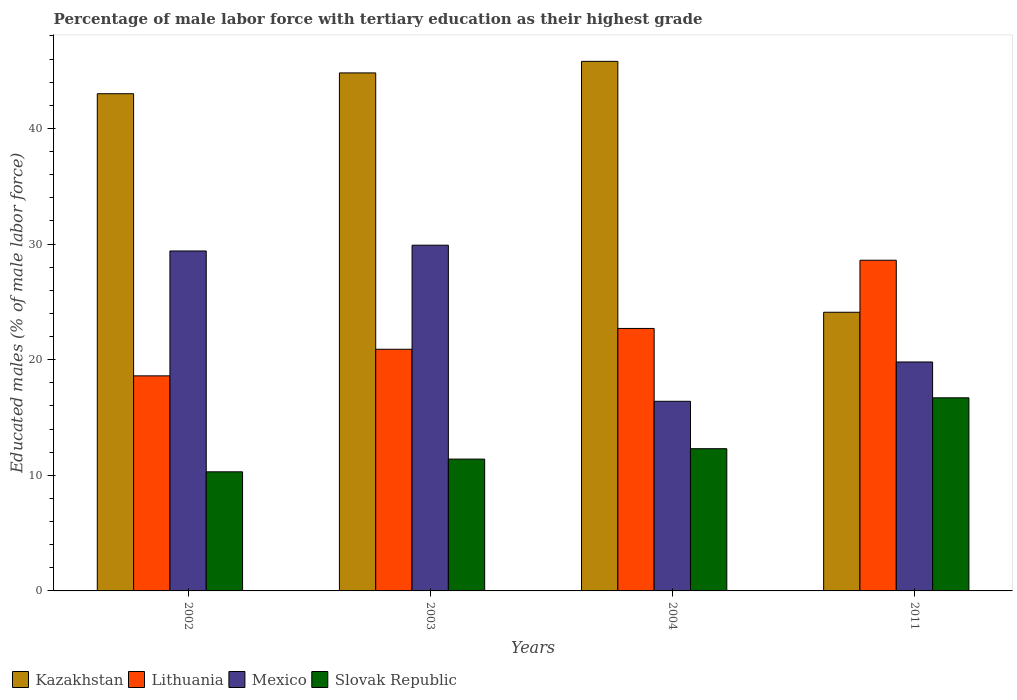In how many cases, is the number of bars for a given year not equal to the number of legend labels?
Provide a succinct answer. 0. What is the percentage of male labor force with tertiary education in Lithuania in 2011?
Ensure brevity in your answer.  28.6. Across all years, what is the maximum percentage of male labor force with tertiary education in Lithuania?
Make the answer very short. 28.6. Across all years, what is the minimum percentage of male labor force with tertiary education in Kazakhstan?
Your answer should be very brief. 24.1. What is the total percentage of male labor force with tertiary education in Mexico in the graph?
Ensure brevity in your answer.  95.5. What is the difference between the percentage of male labor force with tertiary education in Mexico in 2003 and that in 2004?
Your answer should be very brief. 13.5. What is the difference between the percentage of male labor force with tertiary education in Kazakhstan in 2003 and the percentage of male labor force with tertiary education in Mexico in 2004?
Offer a very short reply. 28.4. What is the average percentage of male labor force with tertiary education in Kazakhstan per year?
Your answer should be very brief. 39.42. In the year 2002, what is the difference between the percentage of male labor force with tertiary education in Lithuania and percentage of male labor force with tertiary education in Mexico?
Offer a terse response. -10.8. In how many years, is the percentage of male labor force with tertiary education in Kazakhstan greater than 20 %?
Offer a terse response. 4. What is the ratio of the percentage of male labor force with tertiary education in Lithuania in 2002 to that in 2003?
Your answer should be compact. 0.89. Is the percentage of male labor force with tertiary education in Slovak Republic in 2002 less than that in 2011?
Make the answer very short. Yes. Is the difference between the percentage of male labor force with tertiary education in Lithuania in 2004 and 2011 greater than the difference between the percentage of male labor force with tertiary education in Mexico in 2004 and 2011?
Give a very brief answer. No. What is the difference between the highest and the lowest percentage of male labor force with tertiary education in Slovak Republic?
Provide a short and direct response. 6.4. In how many years, is the percentage of male labor force with tertiary education in Slovak Republic greater than the average percentage of male labor force with tertiary education in Slovak Republic taken over all years?
Keep it short and to the point. 1. What does the 1st bar from the left in 2003 represents?
Your answer should be very brief. Kazakhstan. What does the 2nd bar from the right in 2003 represents?
Offer a terse response. Mexico. What is the difference between two consecutive major ticks on the Y-axis?
Your answer should be very brief. 10. Does the graph contain grids?
Offer a terse response. No. Where does the legend appear in the graph?
Give a very brief answer. Bottom left. What is the title of the graph?
Offer a terse response. Percentage of male labor force with tertiary education as their highest grade. Does "Moldova" appear as one of the legend labels in the graph?
Give a very brief answer. No. What is the label or title of the X-axis?
Ensure brevity in your answer.  Years. What is the label or title of the Y-axis?
Provide a short and direct response. Educated males (% of male labor force). What is the Educated males (% of male labor force) of Kazakhstan in 2002?
Give a very brief answer. 43. What is the Educated males (% of male labor force) in Lithuania in 2002?
Make the answer very short. 18.6. What is the Educated males (% of male labor force) in Mexico in 2002?
Make the answer very short. 29.4. What is the Educated males (% of male labor force) in Slovak Republic in 2002?
Ensure brevity in your answer.  10.3. What is the Educated males (% of male labor force) in Kazakhstan in 2003?
Ensure brevity in your answer.  44.8. What is the Educated males (% of male labor force) in Lithuania in 2003?
Your answer should be very brief. 20.9. What is the Educated males (% of male labor force) in Mexico in 2003?
Give a very brief answer. 29.9. What is the Educated males (% of male labor force) in Slovak Republic in 2003?
Ensure brevity in your answer.  11.4. What is the Educated males (% of male labor force) in Kazakhstan in 2004?
Your answer should be compact. 45.8. What is the Educated males (% of male labor force) of Lithuania in 2004?
Make the answer very short. 22.7. What is the Educated males (% of male labor force) of Mexico in 2004?
Offer a very short reply. 16.4. What is the Educated males (% of male labor force) in Slovak Republic in 2004?
Offer a very short reply. 12.3. What is the Educated males (% of male labor force) of Kazakhstan in 2011?
Your answer should be compact. 24.1. What is the Educated males (% of male labor force) of Lithuania in 2011?
Offer a very short reply. 28.6. What is the Educated males (% of male labor force) in Mexico in 2011?
Ensure brevity in your answer.  19.8. What is the Educated males (% of male labor force) of Slovak Republic in 2011?
Keep it short and to the point. 16.7. Across all years, what is the maximum Educated males (% of male labor force) of Kazakhstan?
Provide a succinct answer. 45.8. Across all years, what is the maximum Educated males (% of male labor force) of Lithuania?
Ensure brevity in your answer.  28.6. Across all years, what is the maximum Educated males (% of male labor force) of Mexico?
Your answer should be very brief. 29.9. Across all years, what is the maximum Educated males (% of male labor force) in Slovak Republic?
Offer a terse response. 16.7. Across all years, what is the minimum Educated males (% of male labor force) in Kazakhstan?
Provide a short and direct response. 24.1. Across all years, what is the minimum Educated males (% of male labor force) in Lithuania?
Keep it short and to the point. 18.6. Across all years, what is the minimum Educated males (% of male labor force) of Mexico?
Offer a terse response. 16.4. Across all years, what is the minimum Educated males (% of male labor force) of Slovak Republic?
Ensure brevity in your answer.  10.3. What is the total Educated males (% of male labor force) of Kazakhstan in the graph?
Give a very brief answer. 157.7. What is the total Educated males (% of male labor force) in Lithuania in the graph?
Offer a terse response. 90.8. What is the total Educated males (% of male labor force) of Mexico in the graph?
Provide a short and direct response. 95.5. What is the total Educated males (% of male labor force) of Slovak Republic in the graph?
Offer a terse response. 50.7. What is the difference between the Educated males (% of male labor force) in Kazakhstan in 2002 and that in 2003?
Keep it short and to the point. -1.8. What is the difference between the Educated males (% of male labor force) of Mexico in 2002 and that in 2003?
Keep it short and to the point. -0.5. What is the difference between the Educated males (% of male labor force) of Kazakhstan in 2002 and that in 2004?
Offer a terse response. -2.8. What is the difference between the Educated males (% of male labor force) in Lithuania in 2002 and that in 2011?
Your answer should be compact. -10. What is the difference between the Educated males (% of male labor force) of Slovak Republic in 2002 and that in 2011?
Your answer should be very brief. -6.4. What is the difference between the Educated males (% of male labor force) in Kazakhstan in 2003 and that in 2011?
Provide a succinct answer. 20.7. What is the difference between the Educated males (% of male labor force) of Lithuania in 2003 and that in 2011?
Keep it short and to the point. -7.7. What is the difference between the Educated males (% of male labor force) in Kazakhstan in 2004 and that in 2011?
Provide a short and direct response. 21.7. What is the difference between the Educated males (% of male labor force) of Lithuania in 2004 and that in 2011?
Offer a terse response. -5.9. What is the difference between the Educated males (% of male labor force) of Kazakhstan in 2002 and the Educated males (% of male labor force) of Lithuania in 2003?
Give a very brief answer. 22.1. What is the difference between the Educated males (% of male labor force) in Kazakhstan in 2002 and the Educated males (% of male labor force) in Slovak Republic in 2003?
Give a very brief answer. 31.6. What is the difference between the Educated males (% of male labor force) of Mexico in 2002 and the Educated males (% of male labor force) of Slovak Republic in 2003?
Make the answer very short. 18. What is the difference between the Educated males (% of male labor force) in Kazakhstan in 2002 and the Educated males (% of male labor force) in Lithuania in 2004?
Give a very brief answer. 20.3. What is the difference between the Educated males (% of male labor force) of Kazakhstan in 2002 and the Educated males (% of male labor force) of Mexico in 2004?
Your answer should be compact. 26.6. What is the difference between the Educated males (% of male labor force) of Kazakhstan in 2002 and the Educated males (% of male labor force) of Slovak Republic in 2004?
Provide a short and direct response. 30.7. What is the difference between the Educated males (% of male labor force) of Lithuania in 2002 and the Educated males (% of male labor force) of Mexico in 2004?
Offer a very short reply. 2.2. What is the difference between the Educated males (% of male labor force) in Lithuania in 2002 and the Educated males (% of male labor force) in Slovak Republic in 2004?
Give a very brief answer. 6.3. What is the difference between the Educated males (% of male labor force) of Mexico in 2002 and the Educated males (% of male labor force) of Slovak Republic in 2004?
Provide a succinct answer. 17.1. What is the difference between the Educated males (% of male labor force) in Kazakhstan in 2002 and the Educated males (% of male labor force) in Lithuania in 2011?
Offer a terse response. 14.4. What is the difference between the Educated males (% of male labor force) of Kazakhstan in 2002 and the Educated males (% of male labor force) of Mexico in 2011?
Give a very brief answer. 23.2. What is the difference between the Educated males (% of male labor force) in Kazakhstan in 2002 and the Educated males (% of male labor force) in Slovak Republic in 2011?
Give a very brief answer. 26.3. What is the difference between the Educated males (% of male labor force) in Lithuania in 2002 and the Educated males (% of male labor force) in Mexico in 2011?
Provide a short and direct response. -1.2. What is the difference between the Educated males (% of male labor force) in Lithuania in 2002 and the Educated males (% of male labor force) in Slovak Republic in 2011?
Give a very brief answer. 1.9. What is the difference between the Educated males (% of male labor force) in Kazakhstan in 2003 and the Educated males (% of male labor force) in Lithuania in 2004?
Ensure brevity in your answer.  22.1. What is the difference between the Educated males (% of male labor force) in Kazakhstan in 2003 and the Educated males (% of male labor force) in Mexico in 2004?
Ensure brevity in your answer.  28.4. What is the difference between the Educated males (% of male labor force) in Kazakhstan in 2003 and the Educated males (% of male labor force) in Slovak Republic in 2004?
Offer a terse response. 32.5. What is the difference between the Educated males (% of male labor force) of Lithuania in 2003 and the Educated males (% of male labor force) of Mexico in 2004?
Your answer should be very brief. 4.5. What is the difference between the Educated males (% of male labor force) in Lithuania in 2003 and the Educated males (% of male labor force) in Slovak Republic in 2004?
Provide a short and direct response. 8.6. What is the difference between the Educated males (% of male labor force) in Mexico in 2003 and the Educated males (% of male labor force) in Slovak Republic in 2004?
Offer a very short reply. 17.6. What is the difference between the Educated males (% of male labor force) of Kazakhstan in 2003 and the Educated males (% of male labor force) of Lithuania in 2011?
Your response must be concise. 16.2. What is the difference between the Educated males (% of male labor force) of Kazakhstan in 2003 and the Educated males (% of male labor force) of Mexico in 2011?
Provide a succinct answer. 25. What is the difference between the Educated males (% of male labor force) in Kazakhstan in 2003 and the Educated males (% of male labor force) in Slovak Republic in 2011?
Ensure brevity in your answer.  28.1. What is the difference between the Educated males (% of male labor force) in Lithuania in 2003 and the Educated males (% of male labor force) in Mexico in 2011?
Your answer should be compact. 1.1. What is the difference between the Educated males (% of male labor force) of Kazakhstan in 2004 and the Educated males (% of male labor force) of Lithuania in 2011?
Give a very brief answer. 17.2. What is the difference between the Educated males (% of male labor force) of Kazakhstan in 2004 and the Educated males (% of male labor force) of Mexico in 2011?
Provide a succinct answer. 26. What is the difference between the Educated males (% of male labor force) in Kazakhstan in 2004 and the Educated males (% of male labor force) in Slovak Republic in 2011?
Your response must be concise. 29.1. What is the difference between the Educated males (% of male labor force) of Lithuania in 2004 and the Educated males (% of male labor force) of Mexico in 2011?
Make the answer very short. 2.9. What is the average Educated males (% of male labor force) of Kazakhstan per year?
Offer a terse response. 39.42. What is the average Educated males (% of male labor force) in Lithuania per year?
Make the answer very short. 22.7. What is the average Educated males (% of male labor force) in Mexico per year?
Give a very brief answer. 23.88. What is the average Educated males (% of male labor force) of Slovak Republic per year?
Make the answer very short. 12.68. In the year 2002, what is the difference between the Educated males (% of male labor force) in Kazakhstan and Educated males (% of male labor force) in Lithuania?
Your response must be concise. 24.4. In the year 2002, what is the difference between the Educated males (% of male labor force) in Kazakhstan and Educated males (% of male labor force) in Slovak Republic?
Ensure brevity in your answer.  32.7. In the year 2003, what is the difference between the Educated males (% of male labor force) of Kazakhstan and Educated males (% of male labor force) of Lithuania?
Your answer should be very brief. 23.9. In the year 2003, what is the difference between the Educated males (% of male labor force) of Kazakhstan and Educated males (% of male labor force) of Mexico?
Offer a very short reply. 14.9. In the year 2003, what is the difference between the Educated males (% of male labor force) in Kazakhstan and Educated males (% of male labor force) in Slovak Republic?
Provide a short and direct response. 33.4. In the year 2003, what is the difference between the Educated males (% of male labor force) in Lithuania and Educated males (% of male labor force) in Mexico?
Your answer should be compact. -9. In the year 2003, what is the difference between the Educated males (% of male labor force) in Lithuania and Educated males (% of male labor force) in Slovak Republic?
Your answer should be very brief. 9.5. In the year 2003, what is the difference between the Educated males (% of male labor force) of Mexico and Educated males (% of male labor force) of Slovak Republic?
Give a very brief answer. 18.5. In the year 2004, what is the difference between the Educated males (% of male labor force) in Kazakhstan and Educated males (% of male labor force) in Lithuania?
Provide a short and direct response. 23.1. In the year 2004, what is the difference between the Educated males (% of male labor force) in Kazakhstan and Educated males (% of male labor force) in Mexico?
Offer a terse response. 29.4. In the year 2004, what is the difference between the Educated males (% of male labor force) in Kazakhstan and Educated males (% of male labor force) in Slovak Republic?
Provide a succinct answer. 33.5. In the year 2004, what is the difference between the Educated males (% of male labor force) in Mexico and Educated males (% of male labor force) in Slovak Republic?
Offer a very short reply. 4.1. In the year 2011, what is the difference between the Educated males (% of male labor force) of Kazakhstan and Educated males (% of male labor force) of Lithuania?
Offer a very short reply. -4.5. In the year 2011, what is the difference between the Educated males (% of male labor force) of Kazakhstan and Educated males (% of male labor force) of Slovak Republic?
Ensure brevity in your answer.  7.4. In the year 2011, what is the difference between the Educated males (% of male labor force) in Lithuania and Educated males (% of male labor force) in Mexico?
Offer a terse response. 8.8. In the year 2011, what is the difference between the Educated males (% of male labor force) of Lithuania and Educated males (% of male labor force) of Slovak Republic?
Your answer should be very brief. 11.9. In the year 2011, what is the difference between the Educated males (% of male labor force) in Mexico and Educated males (% of male labor force) in Slovak Republic?
Your answer should be very brief. 3.1. What is the ratio of the Educated males (% of male labor force) in Kazakhstan in 2002 to that in 2003?
Your answer should be very brief. 0.96. What is the ratio of the Educated males (% of male labor force) of Lithuania in 2002 to that in 2003?
Offer a terse response. 0.89. What is the ratio of the Educated males (% of male labor force) of Mexico in 2002 to that in 2003?
Provide a short and direct response. 0.98. What is the ratio of the Educated males (% of male labor force) of Slovak Republic in 2002 to that in 2003?
Offer a very short reply. 0.9. What is the ratio of the Educated males (% of male labor force) of Kazakhstan in 2002 to that in 2004?
Your answer should be compact. 0.94. What is the ratio of the Educated males (% of male labor force) of Lithuania in 2002 to that in 2004?
Give a very brief answer. 0.82. What is the ratio of the Educated males (% of male labor force) of Mexico in 2002 to that in 2004?
Offer a terse response. 1.79. What is the ratio of the Educated males (% of male labor force) in Slovak Republic in 2002 to that in 2004?
Offer a very short reply. 0.84. What is the ratio of the Educated males (% of male labor force) in Kazakhstan in 2002 to that in 2011?
Your answer should be very brief. 1.78. What is the ratio of the Educated males (% of male labor force) in Lithuania in 2002 to that in 2011?
Offer a terse response. 0.65. What is the ratio of the Educated males (% of male labor force) in Mexico in 2002 to that in 2011?
Make the answer very short. 1.48. What is the ratio of the Educated males (% of male labor force) in Slovak Republic in 2002 to that in 2011?
Your response must be concise. 0.62. What is the ratio of the Educated males (% of male labor force) of Kazakhstan in 2003 to that in 2004?
Make the answer very short. 0.98. What is the ratio of the Educated males (% of male labor force) in Lithuania in 2003 to that in 2004?
Your response must be concise. 0.92. What is the ratio of the Educated males (% of male labor force) of Mexico in 2003 to that in 2004?
Your answer should be very brief. 1.82. What is the ratio of the Educated males (% of male labor force) in Slovak Republic in 2003 to that in 2004?
Keep it short and to the point. 0.93. What is the ratio of the Educated males (% of male labor force) in Kazakhstan in 2003 to that in 2011?
Provide a succinct answer. 1.86. What is the ratio of the Educated males (% of male labor force) of Lithuania in 2003 to that in 2011?
Your answer should be very brief. 0.73. What is the ratio of the Educated males (% of male labor force) in Mexico in 2003 to that in 2011?
Your answer should be very brief. 1.51. What is the ratio of the Educated males (% of male labor force) in Slovak Republic in 2003 to that in 2011?
Provide a short and direct response. 0.68. What is the ratio of the Educated males (% of male labor force) of Kazakhstan in 2004 to that in 2011?
Your answer should be very brief. 1.9. What is the ratio of the Educated males (% of male labor force) of Lithuania in 2004 to that in 2011?
Give a very brief answer. 0.79. What is the ratio of the Educated males (% of male labor force) in Mexico in 2004 to that in 2011?
Your answer should be compact. 0.83. What is the ratio of the Educated males (% of male labor force) in Slovak Republic in 2004 to that in 2011?
Provide a succinct answer. 0.74. What is the difference between the highest and the second highest Educated males (% of male labor force) in Kazakhstan?
Keep it short and to the point. 1. What is the difference between the highest and the second highest Educated males (% of male labor force) in Slovak Republic?
Make the answer very short. 4.4. What is the difference between the highest and the lowest Educated males (% of male labor force) of Kazakhstan?
Provide a short and direct response. 21.7. What is the difference between the highest and the lowest Educated males (% of male labor force) of Lithuania?
Your response must be concise. 10. What is the difference between the highest and the lowest Educated males (% of male labor force) in Slovak Republic?
Your answer should be very brief. 6.4. 